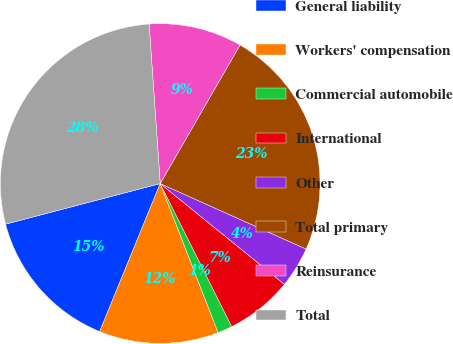Convert chart to OTSL. <chart><loc_0><loc_0><loc_500><loc_500><pie_chart><fcel>General liability<fcel>Workers' compensation<fcel>Commercial automobile<fcel>International<fcel>Other<fcel>Total primary<fcel>Reinsurance<fcel>Total<nl><fcel>14.73%<fcel>12.08%<fcel>1.48%<fcel>6.78%<fcel>4.13%<fcel>23.4%<fcel>9.43%<fcel>27.98%<nl></chart> 